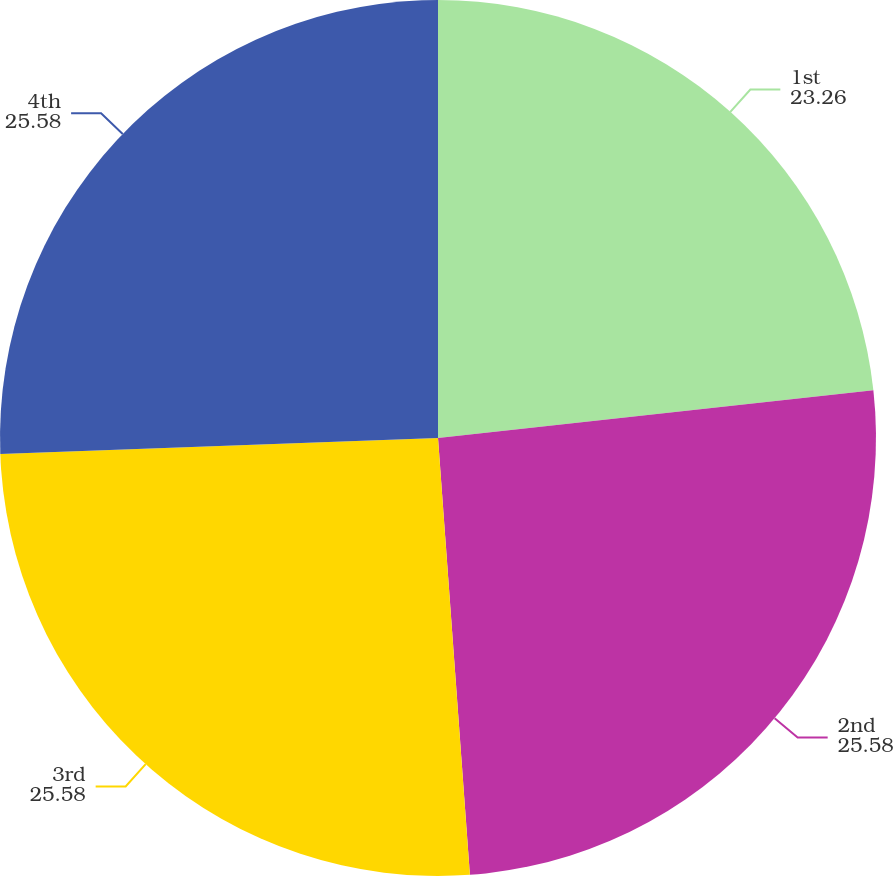<chart> <loc_0><loc_0><loc_500><loc_500><pie_chart><fcel>1st<fcel>2nd<fcel>3rd<fcel>4th<nl><fcel>23.26%<fcel>25.58%<fcel>25.58%<fcel>25.58%<nl></chart> 